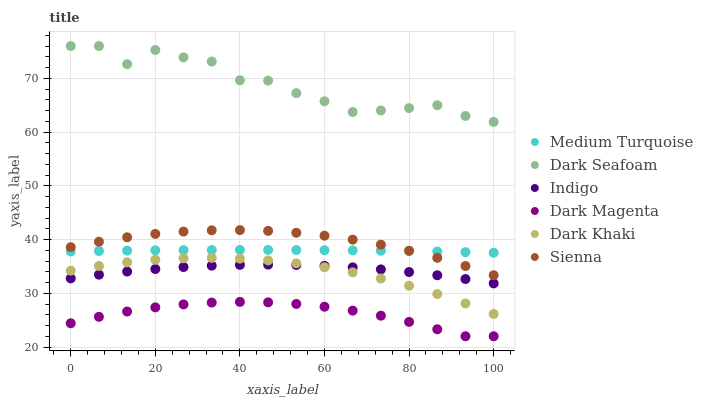Does Dark Magenta have the minimum area under the curve?
Answer yes or no. Yes. Does Dark Seafoam have the maximum area under the curve?
Answer yes or no. Yes. Does Indigo have the minimum area under the curve?
Answer yes or no. No. Does Indigo have the maximum area under the curve?
Answer yes or no. No. Is Medium Turquoise the smoothest?
Answer yes or no. Yes. Is Dark Seafoam the roughest?
Answer yes or no. Yes. Is Indigo the smoothest?
Answer yes or no. No. Is Indigo the roughest?
Answer yes or no. No. Does Dark Magenta have the lowest value?
Answer yes or no. Yes. Does Indigo have the lowest value?
Answer yes or no. No. Does Dark Seafoam have the highest value?
Answer yes or no. Yes. Does Indigo have the highest value?
Answer yes or no. No. Is Dark Magenta less than Dark Seafoam?
Answer yes or no. Yes. Is Dark Seafoam greater than Dark Magenta?
Answer yes or no. Yes. Does Sienna intersect Medium Turquoise?
Answer yes or no. Yes. Is Sienna less than Medium Turquoise?
Answer yes or no. No. Is Sienna greater than Medium Turquoise?
Answer yes or no. No. Does Dark Magenta intersect Dark Seafoam?
Answer yes or no. No. 